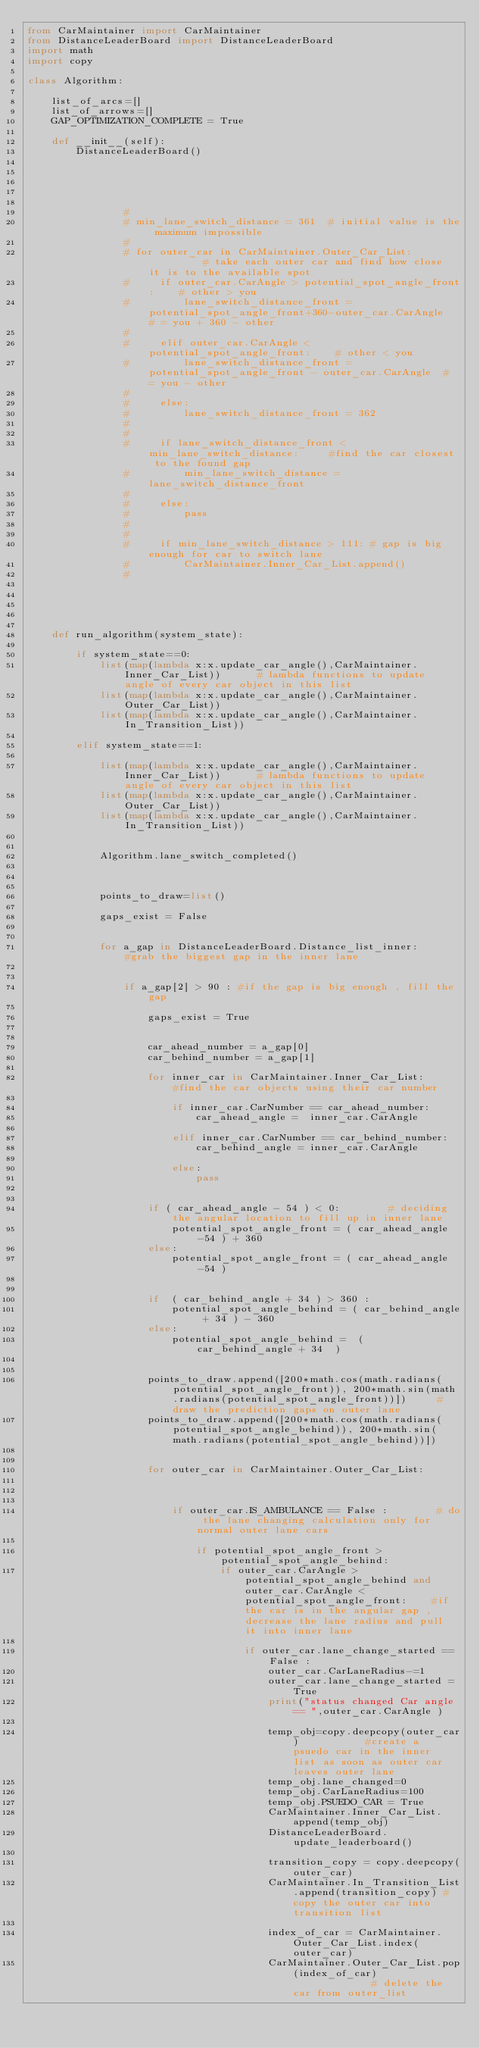<code> <loc_0><loc_0><loc_500><loc_500><_Python_>from CarMaintainer import CarMaintainer
from DistanceLeaderBoard import DistanceLeaderBoard
import math
import copy

class Algorithm:

    list_of_arcs=[]
    list_of_arrows=[]
    GAP_OPTIMIZATION_COMPLETE = True

    def __init__(self):
        DistanceLeaderBoard()





                #
                # min_lane_switch_distance = 361  # initial value is the maximum impossible
                #
                # for outer_car in CarMaintainer.Outer_Car_List:          # take each outer car and find how close it is to the available spot
                #     if outer_car.CarAngle > potential_spot_angle_front:    # other > you
                #         lane_switch_distance_front = potential_spot_angle_front+360-outer_car.CarAngle  # = you + 360 - other
                #
                #     elif outer_car.CarAngle < potential_spot_angle_front:    # other < you
                #         lane_switch_distance_front = potential_spot_angle_front - outer_car.CarAngle  # = you - other
                #
                #     else:
                #         lane_switch_distance_front = 362
                #
                #
                #     if lane_switch_distance_front < min_lane_switch_distance:     #find the car closest to the found gap
                #         min_lane_switch_distance = lane_switch_distance_front
                #
                #     else:
                #         pass
                #
                #
                #     if min_lane_switch_distance > 111: # gap is big enough for car to switch lane
                #         CarMaintainer.Inner_Car_List.append()
                #





    def run_algorithm(system_state):

        if system_state==0:
            list(map(lambda x:x.update_car_angle(),CarMaintainer.Inner_Car_List))      # lambda functions to update angle of every car object in this list
            list(map(lambda x:x.update_car_angle(),CarMaintainer.Outer_Car_List))
            list(map(lambda x:x.update_car_angle(),CarMaintainer.In_Transition_List))

        elif system_state==1:

            list(map(lambda x:x.update_car_angle(),CarMaintainer.Inner_Car_List))      # lambda functions to update angle of every car object in this list
            list(map(lambda x:x.update_car_angle(),CarMaintainer.Outer_Car_List))
            list(map(lambda x:x.update_car_angle(),CarMaintainer.In_Transition_List))


            Algorithm.lane_switch_completed()



            points_to_draw=list()

            gaps_exist = False


            for a_gap in DistanceLeaderBoard.Distance_list_inner:       #grab the biggest gap in the inner lane


                if a_gap[2] > 90 : #if the gap is big enough , fill the gap

                    gaps_exist = True


                    car_ahead_number = a_gap[0]
                    car_behind_number = a_gap[1]

                    for inner_car in CarMaintainer.Inner_Car_List:      #find the car objects using their car number

                        if inner_car.CarNumber == car_ahead_number:
                            car_ahead_angle =  inner_car.CarAngle

                        elif inner_car.CarNumber == car_behind_number:
                            car_behind_angle = inner_car.CarAngle

                        else:
                            pass


                    if ( car_ahead_angle - 54 ) < 0:        # deciding the angular location to fill up in inner lane
                        potential_spot_angle_front = ( car_ahead_angle -54 ) + 360
                    else:
                        potential_spot_angle_front = ( car_ahead_angle -54 )


                    if  ( car_behind_angle + 34 ) > 360 :
                        potential_spot_angle_behind = ( car_behind_angle + 34 ) - 360
                    else:
                        potential_spot_angle_behind =  ( car_behind_angle + 34  )


                    points_to_draw.append([200*math.cos(math.radians(potential_spot_angle_front)), 200*math.sin(math.radians(potential_spot_angle_front))])     #draw the prediction gaps on outer lane
                    points_to_draw.append([200*math.cos(math.radians(potential_spot_angle_behind)), 200*math.sin(math.radians(potential_spot_angle_behind))])


                    for outer_car in CarMaintainer.Outer_Car_List:



                        if outer_car.IS_AMBULANCE == False :        # do the lane changing calculation only for normal outer lane cars

                            if potential_spot_angle_front > potential_spot_angle_behind:
                                if outer_car.CarAngle > potential_spot_angle_behind and outer_car.CarAngle < potential_spot_angle_front:    #if the car is in the angular gap , decrease the lane radius and pull it into inner lane

                                    if outer_car.lane_change_started == False :
                                        outer_car.CarLaneRadius-=1
                                        outer_car.lane_change_started = True
                                        print("status changed Car angle == ",outer_car.CarAngle )

                                        temp_obj=copy.deepcopy(outer_car)           #create a psuedo car in the inner list as soon as outer car leaves outer lane
                                        temp_obj.lane_changed=0
                                        temp_obj.CarLaneRadius=100
                                        temp_obj.PSUEDO_CAR = True
                                        CarMaintainer.Inner_Car_List.append(temp_obj)
                                        DistanceLeaderBoard.update_leaderboard()

                                        transition_copy = copy.deepcopy(outer_car)
                                        CarMaintainer.In_Transition_List.append(transition_copy) #copy the outer car into transition list

                                        index_of_car = CarMaintainer.Outer_Car_List.index(outer_car)
                                        CarMaintainer.Outer_Car_List.pop(index_of_car)              # delete the car from outer_list


</code> 